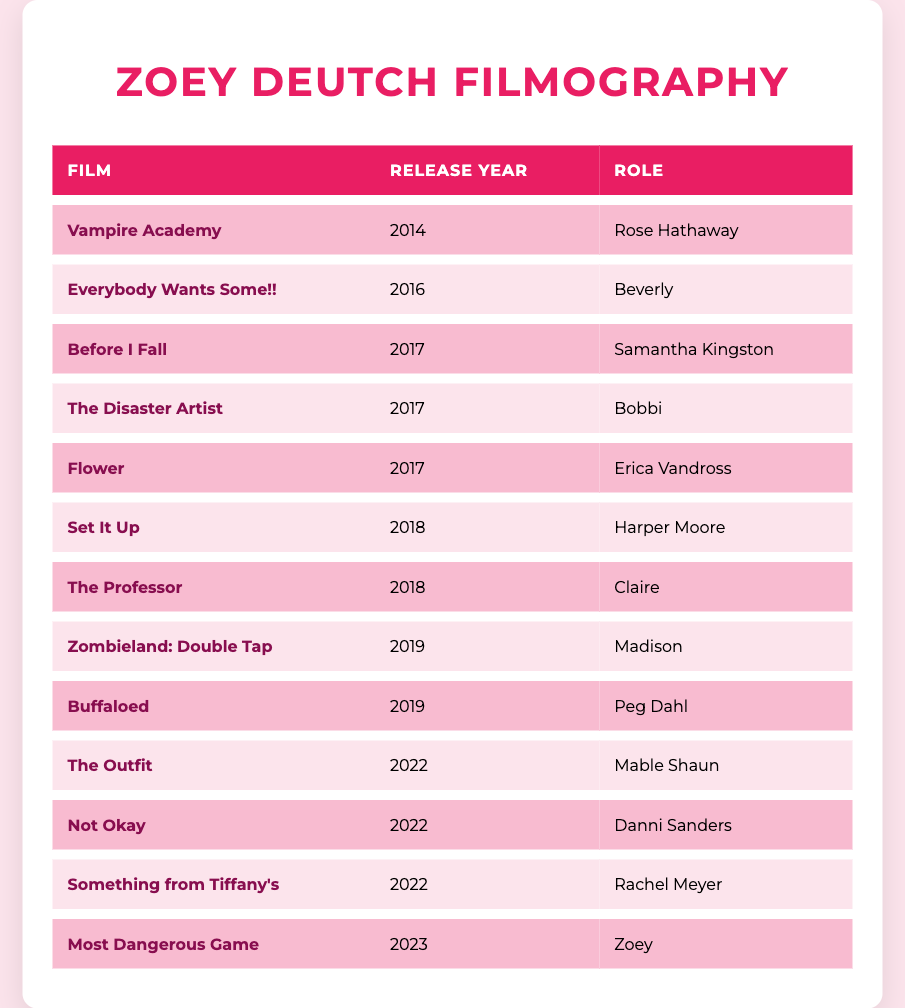What role did Zoey Deutch play in "Before I Fall"? The table lists "Before I Fall" under the Film column, and in the corresponding Role column for that movie, it states that Zoey Deutch played "Samantha Kingston."
Answer: Samantha Kingston In which year was "Zombieland: Double Tap" released? By referring to the table, we can see "Zombieland: Double Tap" in the Film column and check the Release Year column, which indicates it was released in 2019.
Answer: 2019 How many films did Zoey Deutch appear in during 2017? The table can be checked for the Release Year column specifically for the year 2017. There are three entries: "Before I Fall," "The Disaster Artist," and "Flower." Therefore, the count is three films.
Answer: 3 Is "Buffaloed" released before "Set It Up"? Looking at the Release Year column, "Buffaloed" shows a release year of 2019 and "Set It Up" shows a release year of 2018. Since 2019 comes after 2018, "Buffaloed" was released after "Set It Up." Hence, the statement is false.
Answer: No What is the total number of films listed in the table? By counting all the rows in the table under the Film column, excluding the header, we find there are thirteen entries in total: "Vampire Academy," "Everybody Wants Some!!," "Before I Fall," "The Disaster Artist," "Flower," "Set It Up," "The Professor," "Zombieland: Double Tap," "Buffaloed," "The Outfit," "Not Okay," "Something from Tiffany's," and "Most Dangerous Game." Therefore, the total is thirteen films.
Answer: 13 Which role was played by Zoey in the film released in 2023? In the table, examining the Film column under the Release Year of 2023, we find the entry "Most Dangerous Game." The Role column associated with this film indicates that Zoey Deutch played the role of "Zoey."
Answer: Zoey 